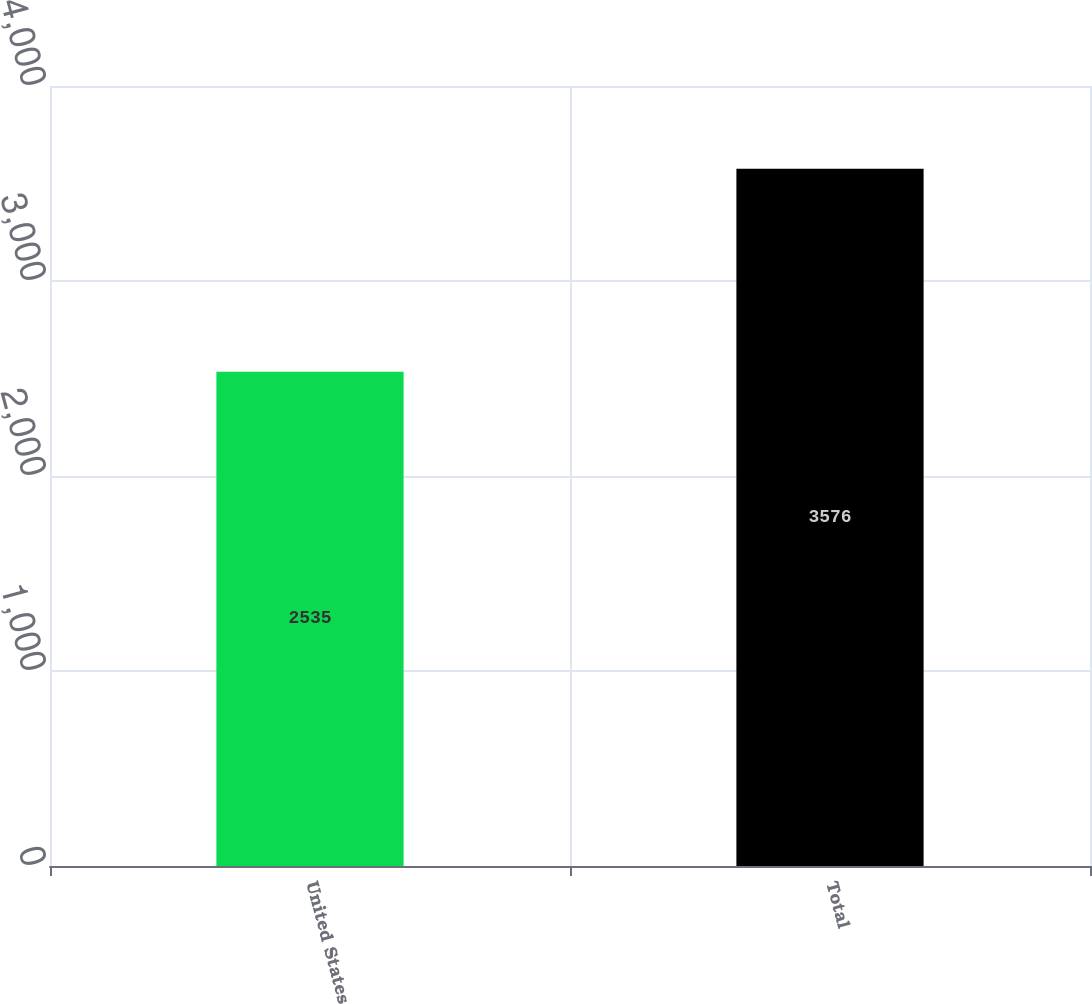Convert chart. <chart><loc_0><loc_0><loc_500><loc_500><bar_chart><fcel>United States<fcel>Total<nl><fcel>2535<fcel>3576<nl></chart> 